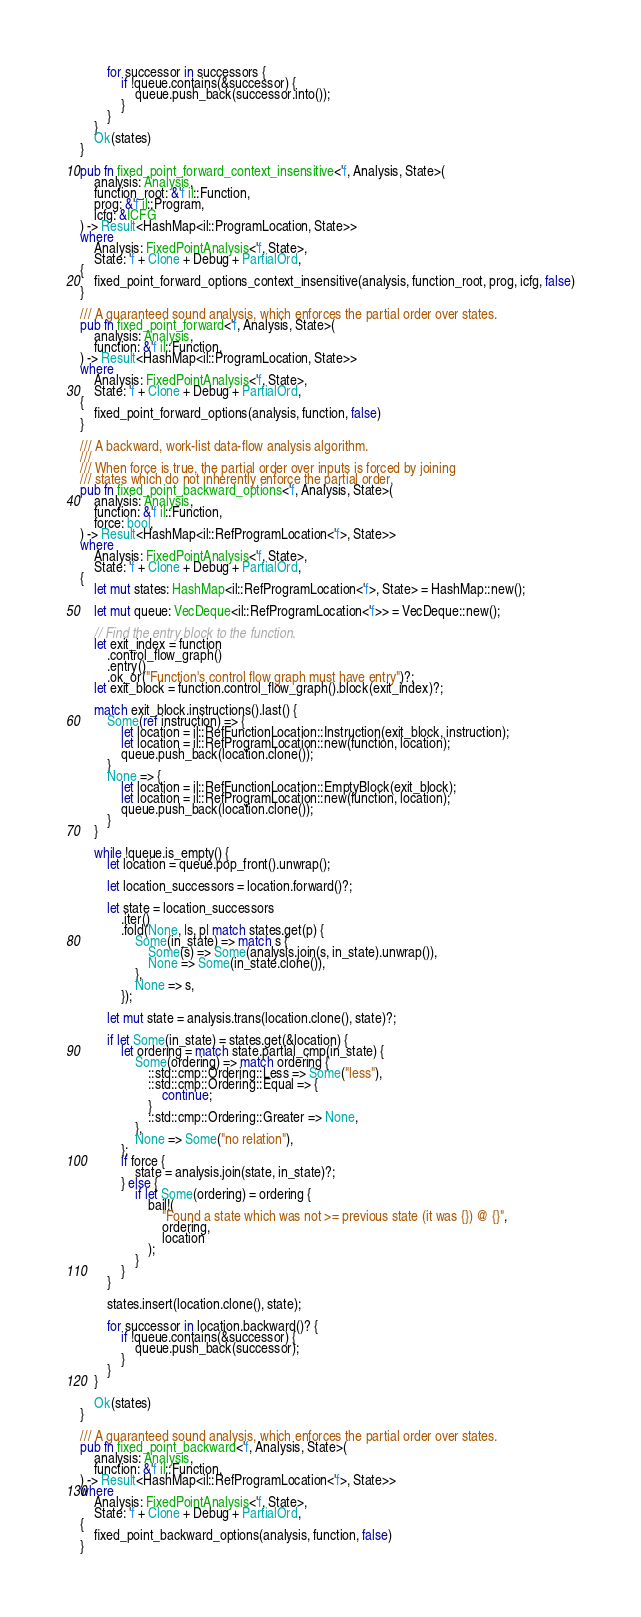Convert code to text. <code><loc_0><loc_0><loc_500><loc_500><_Rust_>        for successor in successors {
            if !queue.contains(&successor) {
                queue.push_back(successor.into());
            }
        }
    }
    Ok(states)
}

pub fn fixed_point_forward_context_insensitive<'f, Analysis, State>(
    analysis: Analysis,
    function_root: &'f il::Function,
    prog: &'f il::Program,
    icfg: &ICFG
) -> Result<HashMap<il::ProgramLocation, State>>
where
    Analysis: FixedPointAnalysis<'f, State>,
    State: 'f + Clone + Debug + PartialOrd,
{
    fixed_point_forward_options_context_insensitive(analysis, function_root, prog, icfg, false)
}

/// A guaranteed sound analysis, which enforces the partial order over states.
pub fn fixed_point_forward<'f, Analysis, State>(
    analysis: Analysis,
    function: &'f il::Function,
) -> Result<HashMap<il::ProgramLocation, State>>
where
    Analysis: FixedPointAnalysis<'f, State>,
    State: 'f + Clone + Debug + PartialOrd,
{
    fixed_point_forward_options(analysis, function, false)
}

/// A backward, work-list data-flow analysis algorithm.
///
/// When force is true, the partial order over inputs is forced by joining
/// states which do not inherently enforce the partial order.
pub fn fixed_point_backward_options<'f, Analysis, State>(
    analysis: Analysis,
    function: &'f il::Function,
    force: bool,
) -> Result<HashMap<il::RefProgramLocation<'f>, State>>
where
    Analysis: FixedPointAnalysis<'f, State>,
    State: 'f + Clone + Debug + PartialOrd,
{
    let mut states: HashMap<il::RefProgramLocation<'f>, State> = HashMap::new();

    let mut queue: VecDeque<il::RefProgramLocation<'f>> = VecDeque::new();

    // Find the entry block to the function.
    let exit_index = function
        .control_flow_graph()
        .entry()
        .ok_or("Function's control flow graph must have entry")?;
    let exit_block = function.control_flow_graph().block(exit_index)?;

    match exit_block.instructions().last() {
        Some(ref instruction) => {
            let location = il::RefFunctionLocation::Instruction(exit_block, instruction);
            let location = il::RefProgramLocation::new(function, location);
            queue.push_back(location.clone());
        }
        None => {
            let location = il::RefFunctionLocation::EmptyBlock(exit_block);
            let location = il::RefProgramLocation::new(function, location);
            queue.push_back(location.clone());
        }
    }

    while !queue.is_empty() {
        let location = queue.pop_front().unwrap();

        let location_successors = location.forward()?;

        let state = location_successors
            .iter()
            .fold(None, |s, p| match states.get(p) {
                Some(in_state) => match s {
                    Some(s) => Some(analysis.join(s, in_state).unwrap()),
                    None => Some(in_state.clone()),
                },
                None => s,
            });

        let mut state = analysis.trans(location.clone(), state)?;

        if let Some(in_state) = states.get(&location) {
            let ordering = match state.partial_cmp(in_state) {
                Some(ordering) => match ordering {
                    ::std::cmp::Ordering::Less => Some("less"),
                    ::std::cmp::Ordering::Equal => {
                        continue;
                    }
                    ::std::cmp::Ordering::Greater => None,
                },
                None => Some("no relation"),
            };
            if force {
                state = analysis.join(state, in_state)?;
            } else {
                if let Some(ordering) = ordering {
                    bail!(
                        "Found a state which was not >= previous state (it was {}) @ {}",
                        ordering,
                        location
                    );
                }
            }
        }

        states.insert(location.clone(), state);

        for successor in location.backward()? {
            if !queue.contains(&successor) {
                queue.push_back(successor);
            }
        }
    }

    Ok(states)
}

/// A guaranteed sound analysis, which enforces the partial order over states.
pub fn fixed_point_backward<'f, Analysis, State>(
    analysis: Analysis,
    function: &'f il::Function,
) -> Result<HashMap<il::RefProgramLocation<'f>, State>>
where
    Analysis: FixedPointAnalysis<'f, State>,
    State: 'f + Clone + Debug + PartialOrd,
{
    fixed_point_backward_options(analysis, function, false)
}
</code> 